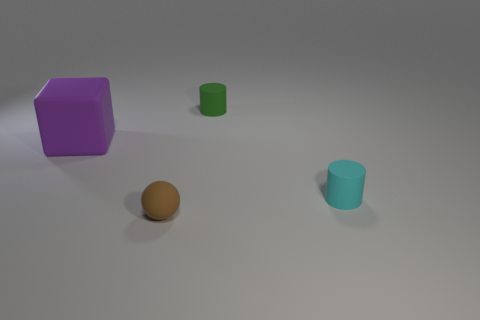Are there any matte blocks in front of the brown rubber object?
Offer a terse response. No. Is the rubber cube the same size as the rubber sphere?
Make the answer very short. No. How many purple things are the same material as the brown thing?
Provide a succinct answer. 1. There is a rubber cylinder behind the object that is on the left side of the ball; what is its size?
Keep it short and to the point. Small. The rubber object that is both behind the small brown matte thing and in front of the purple cube is what color?
Your response must be concise. Cyan. Does the green object have the same shape as the purple rubber object?
Make the answer very short. No. The tiny cyan thing that is on the right side of the thing on the left side of the tiny brown object is what shape?
Provide a succinct answer. Cylinder. Is the shape of the green matte thing the same as the matte thing on the left side of the tiny sphere?
Your response must be concise. No. There is a cylinder that is the same size as the green matte thing; what is its color?
Provide a succinct answer. Cyan. Are there fewer cyan objects that are to the left of the green matte cylinder than tiny matte spheres that are on the right side of the purple thing?
Provide a succinct answer. Yes. 